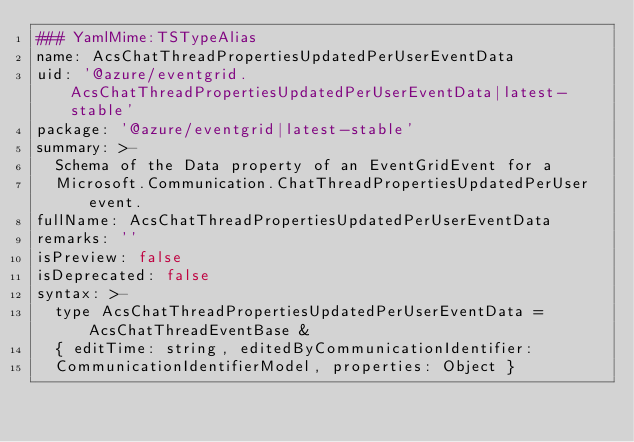<code> <loc_0><loc_0><loc_500><loc_500><_YAML_>### YamlMime:TSTypeAlias
name: AcsChatThreadPropertiesUpdatedPerUserEventData
uid: '@azure/eventgrid.AcsChatThreadPropertiesUpdatedPerUserEventData|latest-stable'
package: '@azure/eventgrid|latest-stable'
summary: >-
  Schema of the Data property of an EventGridEvent for a
  Microsoft.Communication.ChatThreadPropertiesUpdatedPerUser event.
fullName: AcsChatThreadPropertiesUpdatedPerUserEventData
remarks: ''
isPreview: false
isDeprecated: false
syntax: >-
  type AcsChatThreadPropertiesUpdatedPerUserEventData = AcsChatThreadEventBase &
  { editTime: string, editedByCommunicationIdentifier:
  CommunicationIdentifierModel, properties: Object }
</code> 